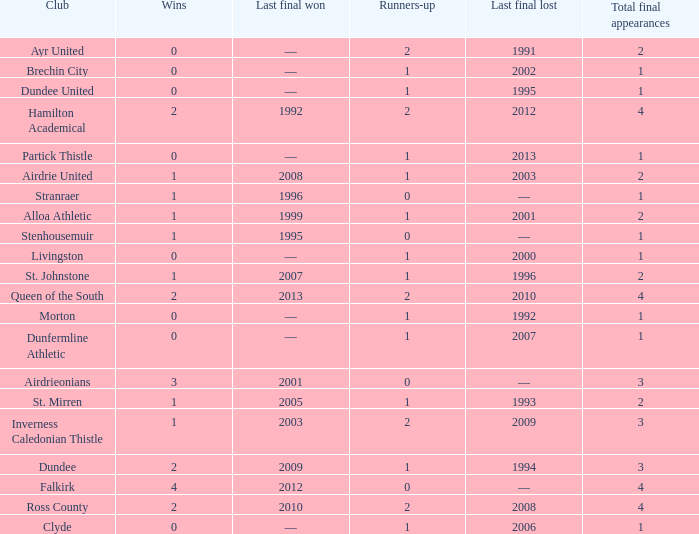What club has over 1 runners-up and last won the final in 2010? Ross County. 